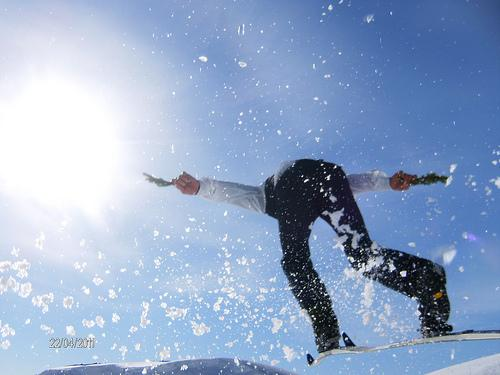In one sentence, describe the scene in the image. A person wearing black pants is skiing or snowboarding on a snowy hill with white snow particles in the air, under a clear blue sky with a bright sun shining. Explain the weather conditions in the image. It is a clear sunny day with snow particles flying in the air. Describe the subject's position in the image with respect to the snowy hill. The person is skiing or snowboarding on the snowy hill, slightly bending over with their hands carrying an object. List three objects and their colors in the image Snowboard - white What color is the person's attire in the image? The person is wearing black pants and white long sleeves. What is the dominant color in the sky? The sky is predominantly blue. What action is the person in the image performing? The person is either skiing or snowboarding on a snowy hill. Identify three objects that can be found in the sky in the image. Sun, white clouds, and clear blue sky. What is the emotion or sentiment conveyed by the image? The sentiment conveyed by the image is excitement and joy from outdoor winter activities. Determine whether the sun is visible in the image. Yes, the sun is visible and bright in the image. Do you see a lighthouse in the distance behind the person skiing? None of the information provided refers to a lighthouse or anything similar. This instruction is misleading, as it asks the user to find an object that is not present in the image. What specific weather condition can be seen in the image? Snowing outside, sunny day. Where is the person's right hand located in the image? The right hand is at (X:380, Y:151, Width:88, Height:88). Can you recognize letters or numbers in the picture? If so, mention the date. Yes, the date on the picture is at (X:46, Y:335, Width:57, Height:57). Is the image taken during a sunny or cloudy day? The sun is shining, but there are also white clouds against the blue sky. Describe the anomalies visible in the image. No anomalies found. How would you assess the image's quality for object detection? The image quality is suitable for object detection tasks. Is there a couple holding hands near the snowboarder? The information given talks only about one person snowboarding, without any mention of a couple or anyone holding hands. This instruction is misleading, as it questions the existence of non-existent subjects within the image. Try to locate a cat wearing a hat in the image. There is no mention of any cat or hat-related object in the given information. The instruction is misleading as it directs the user to look for an object that doesn't exist in the image. Is the image portraying an indoor or outdoor scene? Outdoor scene. Identify the objects and their corresponding image in the image. The sun (X:16, Y:77, Width:94, Height:94), black pants (X:276, Y:165, Width:196, Height:196), person skiing (X:186, Y:125, Width:285, Height:285). Describe the weather conditions illustrated in the image. It is snowing outside, and the sun is bright. Outline the sentiment associated with this image. Positive sentiment, as it captures a person enjoying skiing on a sunny day. What color is the person's shirt sleeve? The sleeve of the shirt is white. Can you find a red balloon floating in the sky? The given information does not mention any balloon or its color. This instruction is misleading, as it asks the user to search for an element not present in the image. List objects the person interacts with in the image. Snowboard, snowflakes, and white long sleeves. There is a flying airplane visible in the background. None of the provided details mention an airplane or anything related to it. This instruction is misleading because it implies the presence of an object that is not in the image. What is the main activity the person is doing in the image? The man is skiing. What is happening with the snow in the image? Snow is flying into the air, and snowflakes are white. Describe the sky's appearance in the image. The sky is blue and clear, with white clouds. A large snowman is standing in the middle of the snowy hill. The provided details do not mention any snowman or related objects. This instruction is misleading because it falsely claims the existence of an object that is not present in the image. 